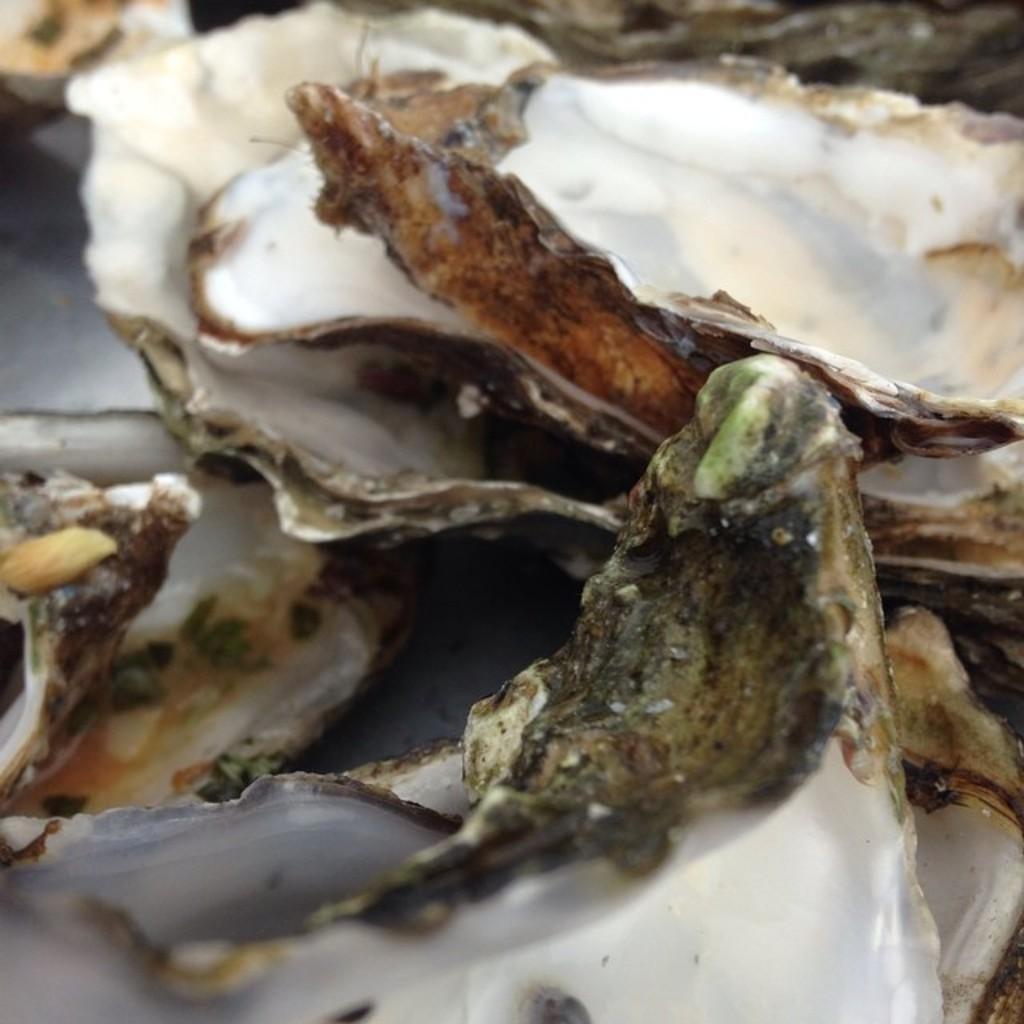Please provide a concise description of this image. In this image we can see some shells on the ground. 